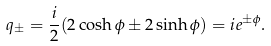<formula> <loc_0><loc_0><loc_500><loc_500>q _ { \pm } = \frac { i } { 2 } ( 2 \cosh { \phi } \pm 2 \sinh { \phi } ) = i e ^ { \pm \phi } .</formula> 